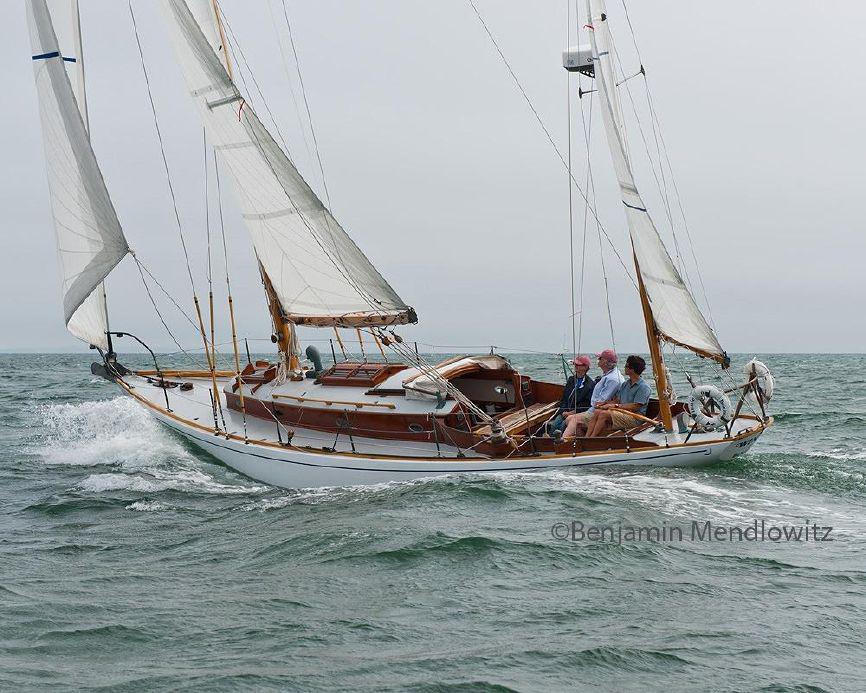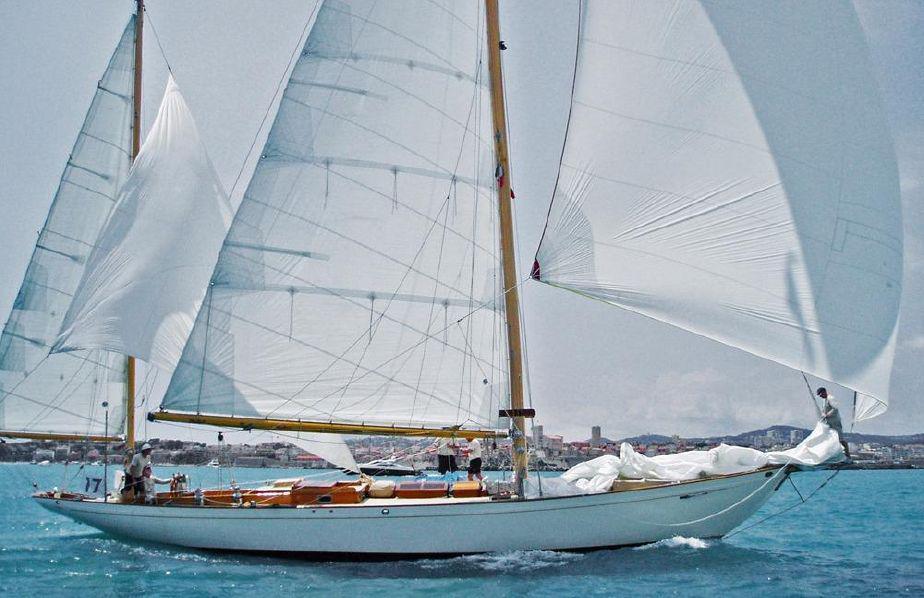The first image is the image on the left, the second image is the image on the right. Assess this claim about the two images: "A striped flag is displayed at the front of a boat.". Correct or not? Answer yes or no. No. The first image is the image on the left, the second image is the image on the right. Analyze the images presented: Is the assertion "There is an American flag visible on a sail boat." valid? Answer yes or no. No. 